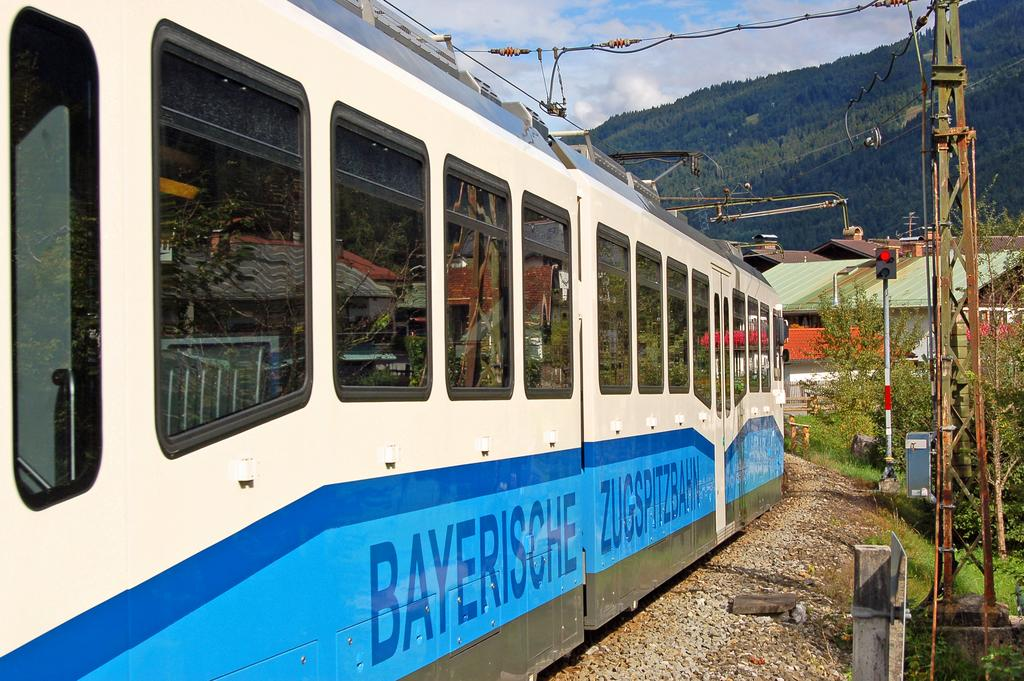<image>
Relay a brief, clear account of the picture shown. A blue and white train reads "BAYERISCHE" on the side 